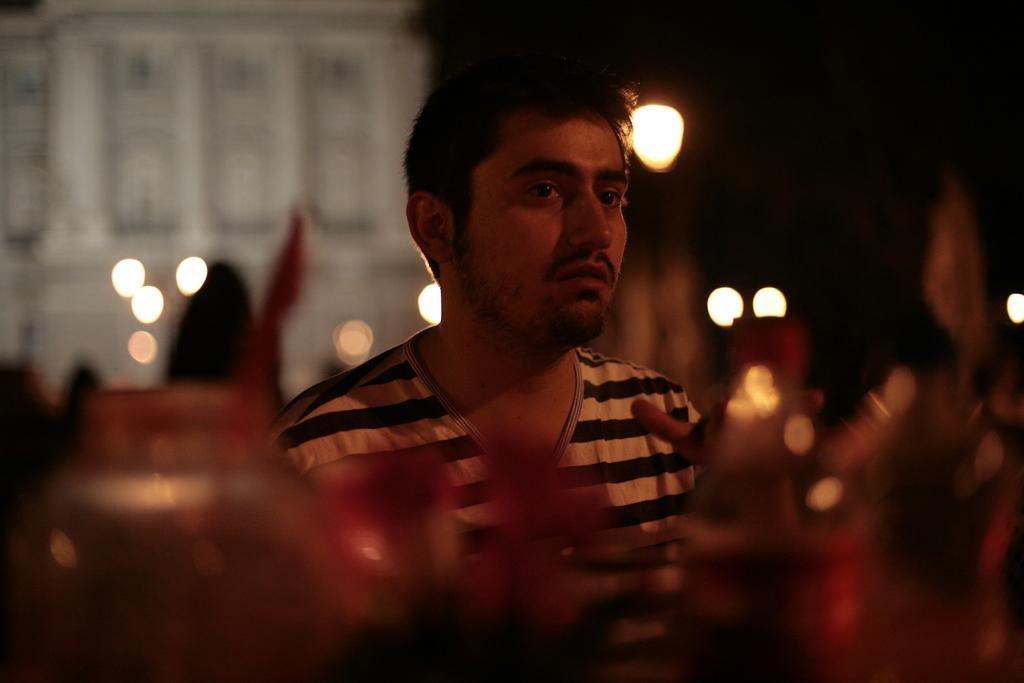Can you describe this image briefly? This picture shows a man and we see a building and few lights. 